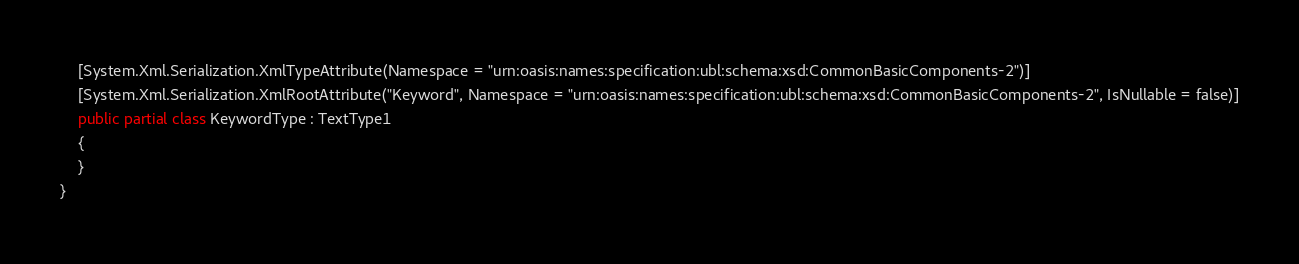<code> <loc_0><loc_0><loc_500><loc_500><_C#_>    [System.Xml.Serialization.XmlTypeAttribute(Namespace = "urn:oasis:names:specification:ubl:schema:xsd:CommonBasicComponents-2")]
    [System.Xml.Serialization.XmlRootAttribute("Keyword", Namespace = "urn:oasis:names:specification:ubl:schema:xsd:CommonBasicComponents-2", IsNullable = false)]
    public partial class KeywordType : TextType1
    {
    }
}</code> 